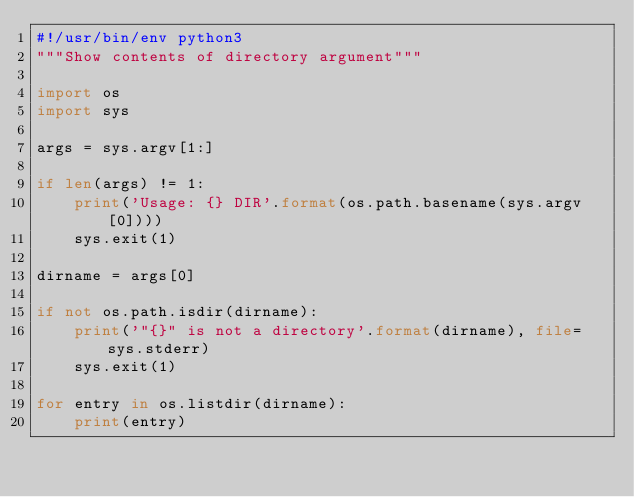Convert code to text. <code><loc_0><loc_0><loc_500><loc_500><_Python_>#!/usr/bin/env python3
"""Show contents of directory argument"""

import os
import sys

args = sys.argv[1:]

if len(args) != 1:
    print('Usage: {} DIR'.format(os.path.basename(sys.argv[0])))
    sys.exit(1)

dirname = args[0]

if not os.path.isdir(dirname):
    print('"{}" is not a directory'.format(dirname), file=sys.stderr)
    sys.exit(1)

for entry in os.listdir(dirname):
    print(entry)
</code> 